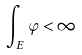Convert formula to latex. <formula><loc_0><loc_0><loc_500><loc_500>\int _ { E } \varphi < \infty</formula> 